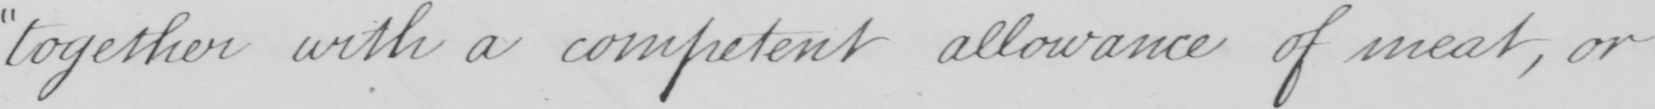Transcribe the text shown in this historical manuscript line. together with a competent allowance of meat , or 